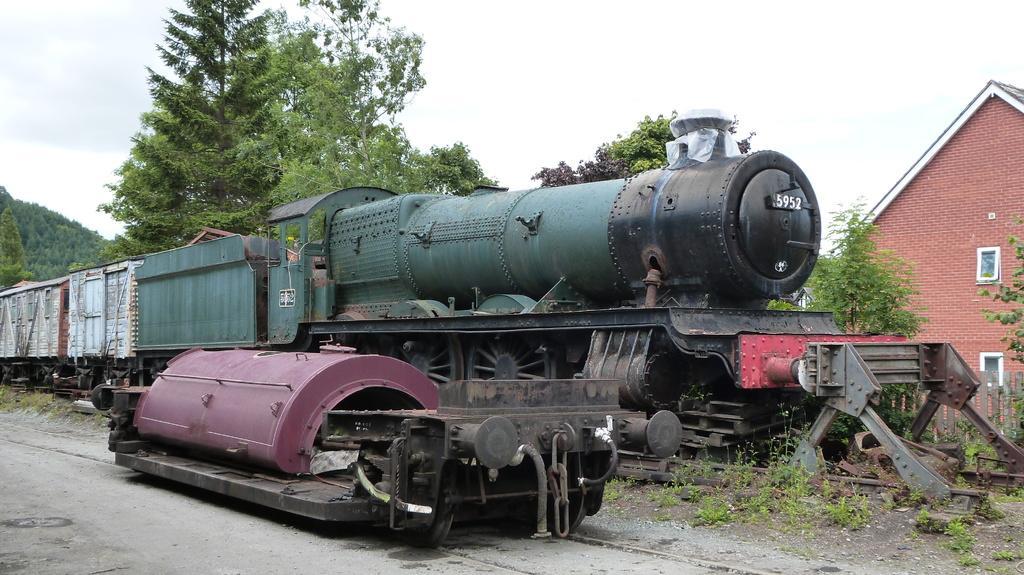Could you give a brief overview of what you see in this image? In the image we can see there is a train standing on the railway track and beside there is an engine machine kept on the ground. Behind there is building and there are trees. 